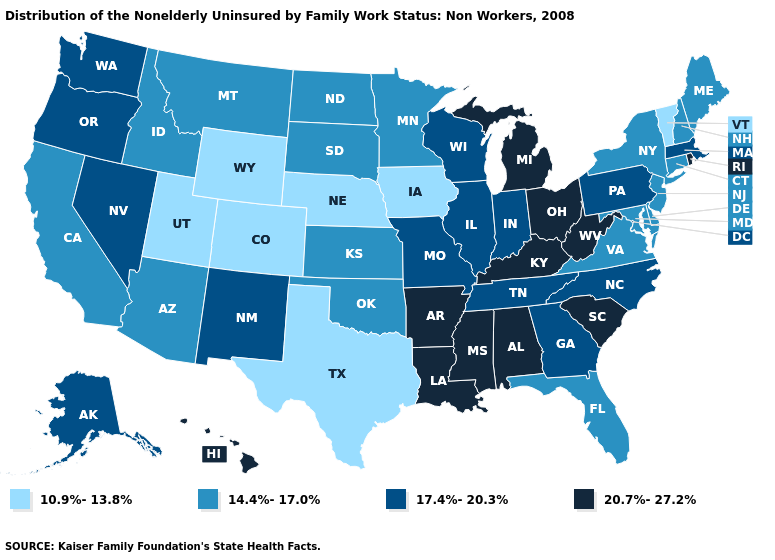Does Massachusetts have a higher value than Michigan?
Give a very brief answer. No. Does Colorado have the same value as Rhode Island?
Quick response, please. No. Among the states that border New Hampshire , does Vermont have the highest value?
Concise answer only. No. Does Kentucky have a lower value than Delaware?
Keep it brief. No. Among the states that border Michigan , does Wisconsin have the lowest value?
Quick response, please. Yes. What is the value of Missouri?
Give a very brief answer. 17.4%-20.3%. Does the map have missing data?
Be succinct. No. Which states have the highest value in the USA?
Quick response, please. Alabama, Arkansas, Hawaii, Kentucky, Louisiana, Michigan, Mississippi, Ohio, Rhode Island, South Carolina, West Virginia. Does Nebraska have the lowest value in the USA?
Short answer required. Yes. Does Florida have a higher value than New Jersey?
Give a very brief answer. No. Does West Virginia have the same value as Maryland?
Write a very short answer. No. What is the value of Vermont?
Keep it brief. 10.9%-13.8%. Name the states that have a value in the range 20.7%-27.2%?
Concise answer only. Alabama, Arkansas, Hawaii, Kentucky, Louisiana, Michigan, Mississippi, Ohio, Rhode Island, South Carolina, West Virginia. What is the value of Alaska?
Give a very brief answer. 17.4%-20.3%. Which states hav the highest value in the MidWest?
Concise answer only. Michigan, Ohio. 